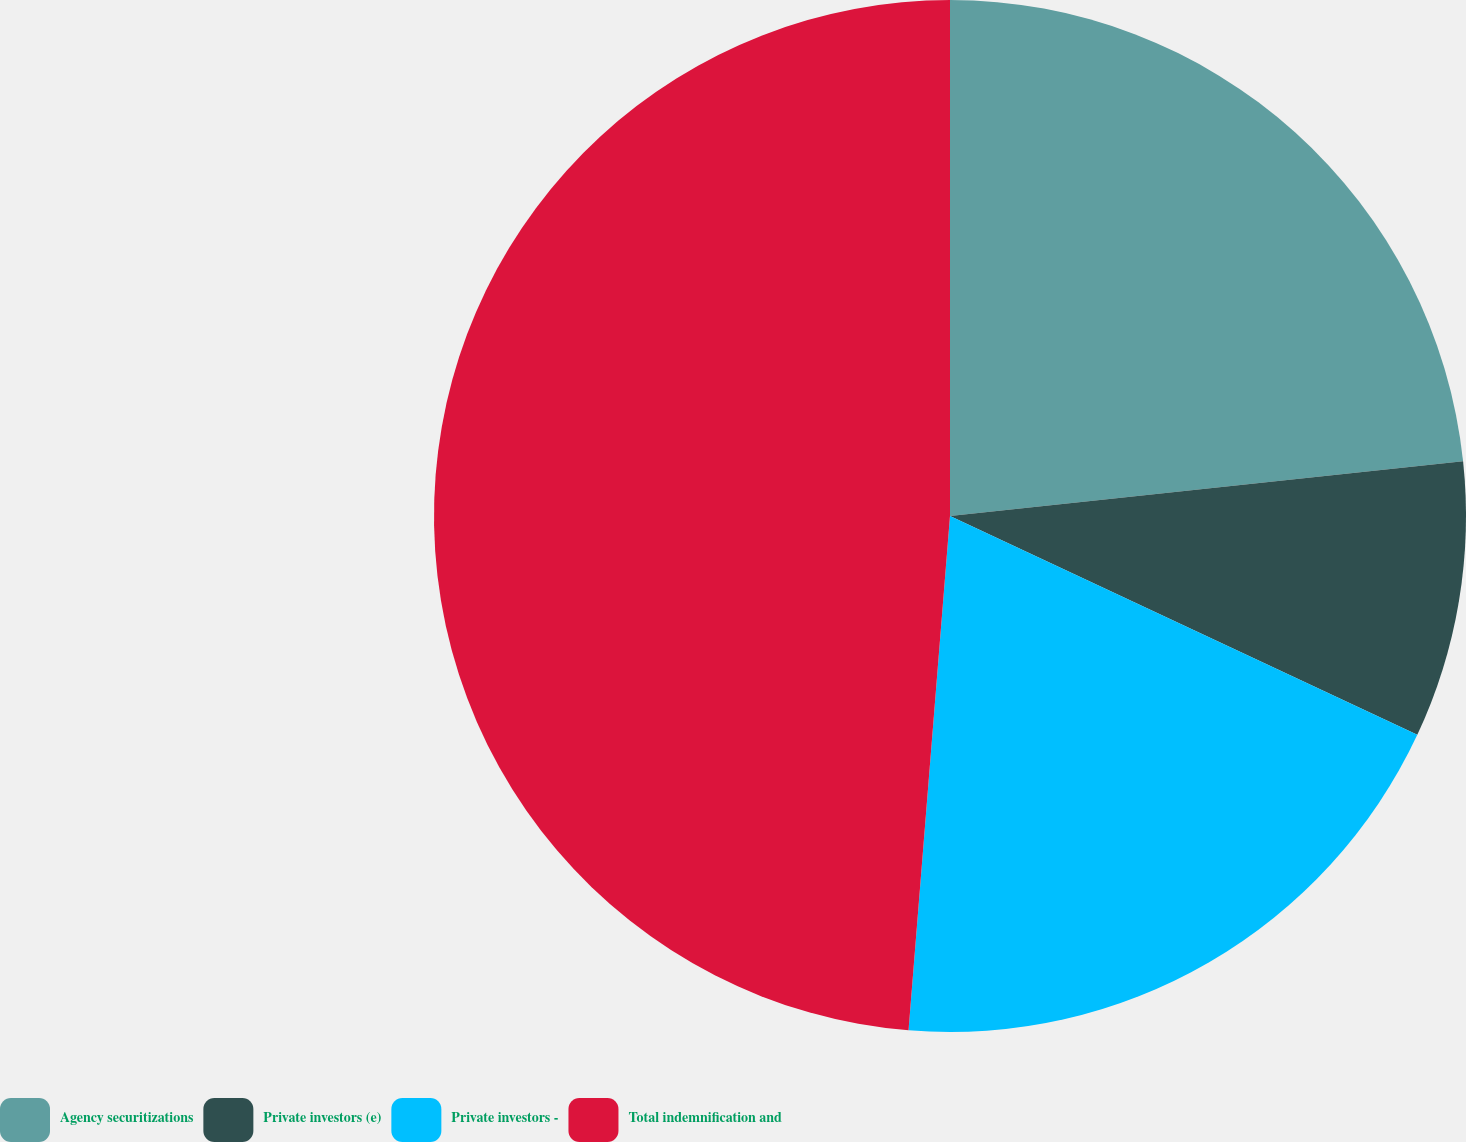Convert chart to OTSL. <chart><loc_0><loc_0><loc_500><loc_500><pie_chart><fcel>Agency securitizations<fcel>Private investors (e)<fcel>Private investors -<fcel>Total indemnification and<nl><fcel>23.31%<fcel>8.66%<fcel>19.31%<fcel>48.72%<nl></chart> 